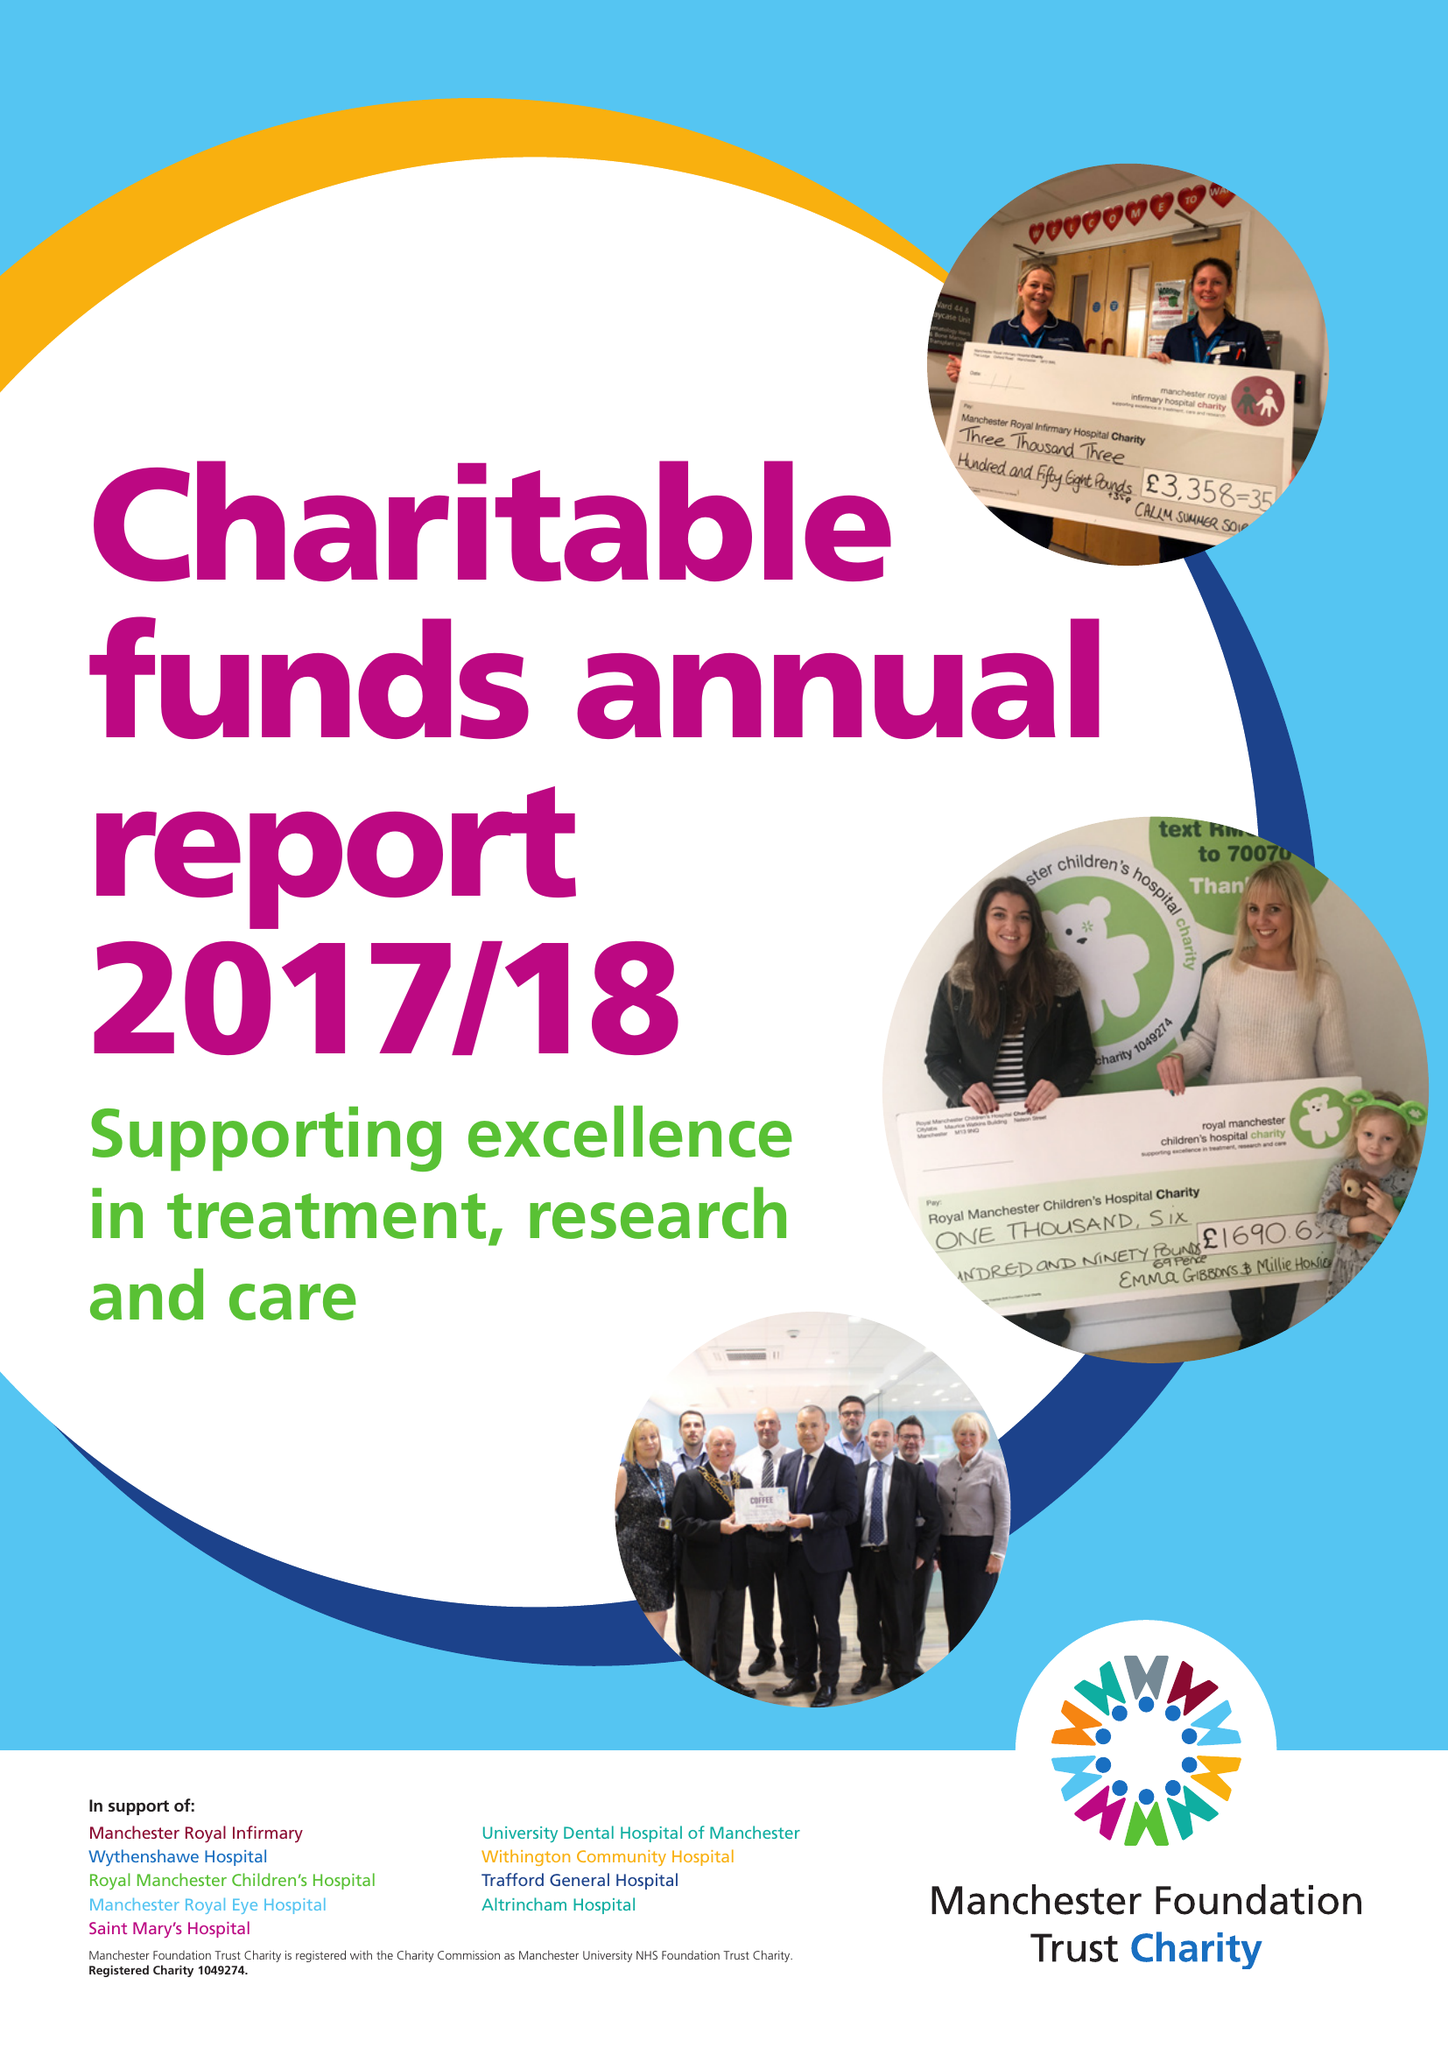What is the value for the income_annually_in_british_pounds?
Answer the question using a single word or phrase. 14022000.00 